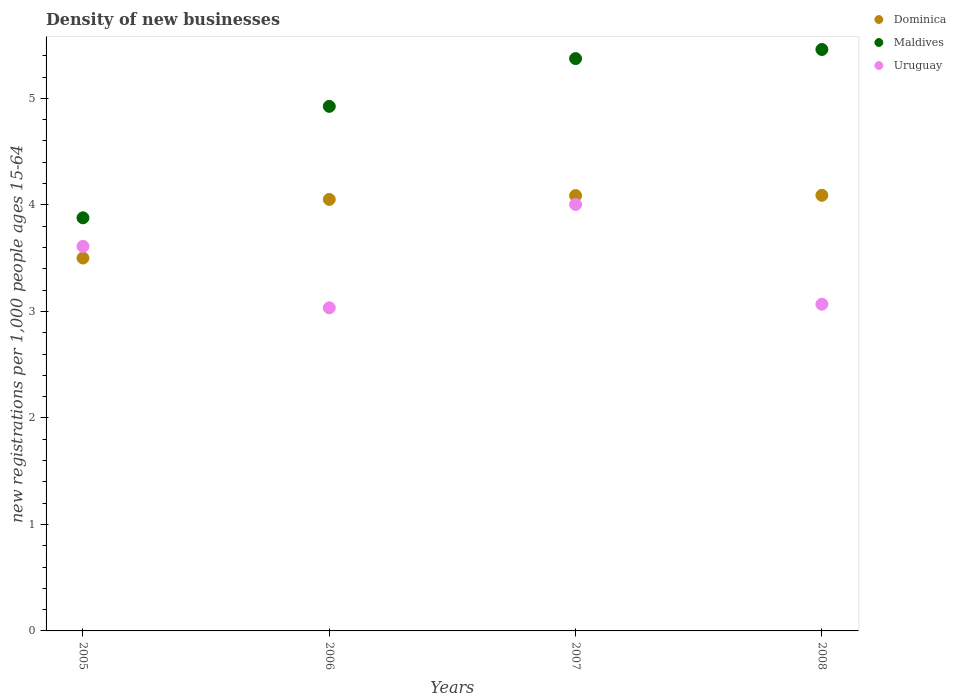How many different coloured dotlines are there?
Keep it short and to the point. 3. Is the number of dotlines equal to the number of legend labels?
Ensure brevity in your answer.  Yes. What is the number of new registrations in Maldives in 2008?
Your answer should be very brief. 5.46. Across all years, what is the maximum number of new registrations in Uruguay?
Your answer should be very brief. 4. Across all years, what is the minimum number of new registrations in Dominica?
Keep it short and to the point. 3.5. What is the total number of new registrations in Uruguay in the graph?
Provide a short and direct response. 13.72. What is the difference between the number of new registrations in Uruguay in 2007 and that in 2008?
Offer a very short reply. 0.94. What is the difference between the number of new registrations in Maldives in 2006 and the number of new registrations in Uruguay in 2008?
Ensure brevity in your answer.  1.86. What is the average number of new registrations in Uruguay per year?
Offer a very short reply. 3.43. In the year 2005, what is the difference between the number of new registrations in Maldives and number of new registrations in Dominica?
Provide a short and direct response. 0.38. What is the ratio of the number of new registrations in Uruguay in 2005 to that in 2006?
Make the answer very short. 1.19. Is the difference between the number of new registrations in Maldives in 2006 and 2007 greater than the difference between the number of new registrations in Dominica in 2006 and 2007?
Provide a succinct answer. No. What is the difference between the highest and the second highest number of new registrations in Dominica?
Offer a very short reply. 0. What is the difference between the highest and the lowest number of new registrations in Uruguay?
Keep it short and to the point. 0.97. In how many years, is the number of new registrations in Maldives greater than the average number of new registrations in Maldives taken over all years?
Provide a succinct answer. 3. Is it the case that in every year, the sum of the number of new registrations in Dominica and number of new registrations in Uruguay  is greater than the number of new registrations in Maldives?
Provide a succinct answer. Yes. Does the number of new registrations in Dominica monotonically increase over the years?
Give a very brief answer. Yes. Is the number of new registrations in Uruguay strictly greater than the number of new registrations in Maldives over the years?
Give a very brief answer. No. Is the number of new registrations in Maldives strictly less than the number of new registrations in Dominica over the years?
Your response must be concise. No. Are the values on the major ticks of Y-axis written in scientific E-notation?
Offer a terse response. No. Where does the legend appear in the graph?
Offer a very short reply. Top right. How are the legend labels stacked?
Provide a succinct answer. Vertical. What is the title of the graph?
Your response must be concise. Density of new businesses. Does "Sweden" appear as one of the legend labels in the graph?
Make the answer very short. No. What is the label or title of the X-axis?
Provide a succinct answer. Years. What is the label or title of the Y-axis?
Your response must be concise. New registrations per 1,0 people ages 15-64. What is the new registrations per 1,000 people ages 15-64 in Dominica in 2005?
Your answer should be very brief. 3.5. What is the new registrations per 1,000 people ages 15-64 of Maldives in 2005?
Give a very brief answer. 3.88. What is the new registrations per 1,000 people ages 15-64 in Uruguay in 2005?
Provide a short and direct response. 3.61. What is the new registrations per 1,000 people ages 15-64 in Dominica in 2006?
Your answer should be very brief. 4.05. What is the new registrations per 1,000 people ages 15-64 in Maldives in 2006?
Your response must be concise. 4.93. What is the new registrations per 1,000 people ages 15-64 in Uruguay in 2006?
Your response must be concise. 3.03. What is the new registrations per 1,000 people ages 15-64 of Dominica in 2007?
Offer a very short reply. 4.09. What is the new registrations per 1,000 people ages 15-64 of Maldives in 2007?
Give a very brief answer. 5.37. What is the new registrations per 1,000 people ages 15-64 of Uruguay in 2007?
Provide a succinct answer. 4. What is the new registrations per 1,000 people ages 15-64 in Dominica in 2008?
Provide a short and direct response. 4.09. What is the new registrations per 1,000 people ages 15-64 in Maldives in 2008?
Make the answer very short. 5.46. What is the new registrations per 1,000 people ages 15-64 of Uruguay in 2008?
Your response must be concise. 3.07. Across all years, what is the maximum new registrations per 1,000 people ages 15-64 of Dominica?
Provide a succinct answer. 4.09. Across all years, what is the maximum new registrations per 1,000 people ages 15-64 of Maldives?
Ensure brevity in your answer.  5.46. Across all years, what is the maximum new registrations per 1,000 people ages 15-64 of Uruguay?
Give a very brief answer. 4. Across all years, what is the minimum new registrations per 1,000 people ages 15-64 in Dominica?
Ensure brevity in your answer.  3.5. Across all years, what is the minimum new registrations per 1,000 people ages 15-64 of Maldives?
Keep it short and to the point. 3.88. Across all years, what is the minimum new registrations per 1,000 people ages 15-64 in Uruguay?
Your response must be concise. 3.03. What is the total new registrations per 1,000 people ages 15-64 in Dominica in the graph?
Your response must be concise. 15.73. What is the total new registrations per 1,000 people ages 15-64 of Maldives in the graph?
Offer a very short reply. 19.64. What is the total new registrations per 1,000 people ages 15-64 in Uruguay in the graph?
Provide a short and direct response. 13.72. What is the difference between the new registrations per 1,000 people ages 15-64 of Dominica in 2005 and that in 2006?
Your answer should be very brief. -0.55. What is the difference between the new registrations per 1,000 people ages 15-64 of Maldives in 2005 and that in 2006?
Offer a very short reply. -1.05. What is the difference between the new registrations per 1,000 people ages 15-64 of Uruguay in 2005 and that in 2006?
Your answer should be very brief. 0.58. What is the difference between the new registrations per 1,000 people ages 15-64 in Dominica in 2005 and that in 2007?
Your answer should be very brief. -0.59. What is the difference between the new registrations per 1,000 people ages 15-64 in Maldives in 2005 and that in 2007?
Give a very brief answer. -1.5. What is the difference between the new registrations per 1,000 people ages 15-64 of Uruguay in 2005 and that in 2007?
Offer a very short reply. -0.39. What is the difference between the new registrations per 1,000 people ages 15-64 in Dominica in 2005 and that in 2008?
Your answer should be compact. -0.59. What is the difference between the new registrations per 1,000 people ages 15-64 of Maldives in 2005 and that in 2008?
Provide a succinct answer. -1.58. What is the difference between the new registrations per 1,000 people ages 15-64 in Uruguay in 2005 and that in 2008?
Give a very brief answer. 0.54. What is the difference between the new registrations per 1,000 people ages 15-64 in Dominica in 2006 and that in 2007?
Offer a very short reply. -0.04. What is the difference between the new registrations per 1,000 people ages 15-64 of Maldives in 2006 and that in 2007?
Ensure brevity in your answer.  -0.45. What is the difference between the new registrations per 1,000 people ages 15-64 in Uruguay in 2006 and that in 2007?
Offer a very short reply. -0.97. What is the difference between the new registrations per 1,000 people ages 15-64 of Dominica in 2006 and that in 2008?
Offer a very short reply. -0.04. What is the difference between the new registrations per 1,000 people ages 15-64 in Maldives in 2006 and that in 2008?
Offer a terse response. -0.53. What is the difference between the new registrations per 1,000 people ages 15-64 of Uruguay in 2006 and that in 2008?
Ensure brevity in your answer.  -0.03. What is the difference between the new registrations per 1,000 people ages 15-64 in Dominica in 2007 and that in 2008?
Give a very brief answer. -0. What is the difference between the new registrations per 1,000 people ages 15-64 of Maldives in 2007 and that in 2008?
Provide a short and direct response. -0.09. What is the difference between the new registrations per 1,000 people ages 15-64 of Uruguay in 2007 and that in 2008?
Your response must be concise. 0.94. What is the difference between the new registrations per 1,000 people ages 15-64 in Dominica in 2005 and the new registrations per 1,000 people ages 15-64 in Maldives in 2006?
Your answer should be very brief. -1.42. What is the difference between the new registrations per 1,000 people ages 15-64 in Dominica in 2005 and the new registrations per 1,000 people ages 15-64 in Uruguay in 2006?
Your answer should be very brief. 0.47. What is the difference between the new registrations per 1,000 people ages 15-64 of Maldives in 2005 and the new registrations per 1,000 people ages 15-64 of Uruguay in 2006?
Provide a short and direct response. 0.84. What is the difference between the new registrations per 1,000 people ages 15-64 in Dominica in 2005 and the new registrations per 1,000 people ages 15-64 in Maldives in 2007?
Keep it short and to the point. -1.87. What is the difference between the new registrations per 1,000 people ages 15-64 of Dominica in 2005 and the new registrations per 1,000 people ages 15-64 of Uruguay in 2007?
Your answer should be very brief. -0.5. What is the difference between the new registrations per 1,000 people ages 15-64 in Maldives in 2005 and the new registrations per 1,000 people ages 15-64 in Uruguay in 2007?
Ensure brevity in your answer.  -0.13. What is the difference between the new registrations per 1,000 people ages 15-64 of Dominica in 2005 and the new registrations per 1,000 people ages 15-64 of Maldives in 2008?
Your answer should be compact. -1.96. What is the difference between the new registrations per 1,000 people ages 15-64 in Dominica in 2005 and the new registrations per 1,000 people ages 15-64 in Uruguay in 2008?
Keep it short and to the point. 0.43. What is the difference between the new registrations per 1,000 people ages 15-64 in Maldives in 2005 and the new registrations per 1,000 people ages 15-64 in Uruguay in 2008?
Your response must be concise. 0.81. What is the difference between the new registrations per 1,000 people ages 15-64 of Dominica in 2006 and the new registrations per 1,000 people ages 15-64 of Maldives in 2007?
Give a very brief answer. -1.32. What is the difference between the new registrations per 1,000 people ages 15-64 in Dominica in 2006 and the new registrations per 1,000 people ages 15-64 in Uruguay in 2007?
Ensure brevity in your answer.  0.05. What is the difference between the new registrations per 1,000 people ages 15-64 of Maldives in 2006 and the new registrations per 1,000 people ages 15-64 of Uruguay in 2007?
Give a very brief answer. 0.92. What is the difference between the new registrations per 1,000 people ages 15-64 in Dominica in 2006 and the new registrations per 1,000 people ages 15-64 in Maldives in 2008?
Offer a very short reply. -1.41. What is the difference between the new registrations per 1,000 people ages 15-64 in Dominica in 2006 and the new registrations per 1,000 people ages 15-64 in Uruguay in 2008?
Your response must be concise. 0.98. What is the difference between the new registrations per 1,000 people ages 15-64 in Maldives in 2006 and the new registrations per 1,000 people ages 15-64 in Uruguay in 2008?
Provide a short and direct response. 1.86. What is the difference between the new registrations per 1,000 people ages 15-64 of Dominica in 2007 and the new registrations per 1,000 people ages 15-64 of Maldives in 2008?
Give a very brief answer. -1.37. What is the difference between the new registrations per 1,000 people ages 15-64 of Dominica in 2007 and the new registrations per 1,000 people ages 15-64 of Uruguay in 2008?
Ensure brevity in your answer.  1.02. What is the difference between the new registrations per 1,000 people ages 15-64 of Maldives in 2007 and the new registrations per 1,000 people ages 15-64 of Uruguay in 2008?
Offer a terse response. 2.31. What is the average new registrations per 1,000 people ages 15-64 of Dominica per year?
Keep it short and to the point. 3.93. What is the average new registrations per 1,000 people ages 15-64 in Maldives per year?
Your response must be concise. 4.91. What is the average new registrations per 1,000 people ages 15-64 of Uruguay per year?
Offer a terse response. 3.43. In the year 2005, what is the difference between the new registrations per 1,000 people ages 15-64 in Dominica and new registrations per 1,000 people ages 15-64 in Maldives?
Offer a terse response. -0.38. In the year 2005, what is the difference between the new registrations per 1,000 people ages 15-64 in Dominica and new registrations per 1,000 people ages 15-64 in Uruguay?
Your response must be concise. -0.11. In the year 2005, what is the difference between the new registrations per 1,000 people ages 15-64 in Maldives and new registrations per 1,000 people ages 15-64 in Uruguay?
Ensure brevity in your answer.  0.27. In the year 2006, what is the difference between the new registrations per 1,000 people ages 15-64 in Dominica and new registrations per 1,000 people ages 15-64 in Maldives?
Offer a very short reply. -0.87. In the year 2006, what is the difference between the new registrations per 1,000 people ages 15-64 of Dominica and new registrations per 1,000 people ages 15-64 of Uruguay?
Provide a short and direct response. 1.02. In the year 2006, what is the difference between the new registrations per 1,000 people ages 15-64 in Maldives and new registrations per 1,000 people ages 15-64 in Uruguay?
Ensure brevity in your answer.  1.89. In the year 2007, what is the difference between the new registrations per 1,000 people ages 15-64 of Dominica and new registrations per 1,000 people ages 15-64 of Maldives?
Your response must be concise. -1.29. In the year 2007, what is the difference between the new registrations per 1,000 people ages 15-64 in Dominica and new registrations per 1,000 people ages 15-64 in Uruguay?
Keep it short and to the point. 0.08. In the year 2007, what is the difference between the new registrations per 1,000 people ages 15-64 in Maldives and new registrations per 1,000 people ages 15-64 in Uruguay?
Your response must be concise. 1.37. In the year 2008, what is the difference between the new registrations per 1,000 people ages 15-64 in Dominica and new registrations per 1,000 people ages 15-64 in Maldives?
Offer a terse response. -1.37. In the year 2008, what is the difference between the new registrations per 1,000 people ages 15-64 in Dominica and new registrations per 1,000 people ages 15-64 in Uruguay?
Keep it short and to the point. 1.02. In the year 2008, what is the difference between the new registrations per 1,000 people ages 15-64 in Maldives and new registrations per 1,000 people ages 15-64 in Uruguay?
Ensure brevity in your answer.  2.39. What is the ratio of the new registrations per 1,000 people ages 15-64 in Dominica in 2005 to that in 2006?
Offer a very short reply. 0.86. What is the ratio of the new registrations per 1,000 people ages 15-64 in Maldives in 2005 to that in 2006?
Offer a terse response. 0.79. What is the ratio of the new registrations per 1,000 people ages 15-64 in Uruguay in 2005 to that in 2006?
Give a very brief answer. 1.19. What is the ratio of the new registrations per 1,000 people ages 15-64 of Dominica in 2005 to that in 2007?
Your response must be concise. 0.86. What is the ratio of the new registrations per 1,000 people ages 15-64 in Maldives in 2005 to that in 2007?
Make the answer very short. 0.72. What is the ratio of the new registrations per 1,000 people ages 15-64 in Uruguay in 2005 to that in 2007?
Your response must be concise. 0.9. What is the ratio of the new registrations per 1,000 people ages 15-64 of Dominica in 2005 to that in 2008?
Give a very brief answer. 0.86. What is the ratio of the new registrations per 1,000 people ages 15-64 of Maldives in 2005 to that in 2008?
Offer a very short reply. 0.71. What is the ratio of the new registrations per 1,000 people ages 15-64 in Uruguay in 2005 to that in 2008?
Provide a succinct answer. 1.18. What is the ratio of the new registrations per 1,000 people ages 15-64 of Dominica in 2006 to that in 2007?
Make the answer very short. 0.99. What is the ratio of the new registrations per 1,000 people ages 15-64 of Maldives in 2006 to that in 2007?
Give a very brief answer. 0.92. What is the ratio of the new registrations per 1,000 people ages 15-64 of Uruguay in 2006 to that in 2007?
Your answer should be very brief. 0.76. What is the ratio of the new registrations per 1,000 people ages 15-64 of Dominica in 2006 to that in 2008?
Ensure brevity in your answer.  0.99. What is the ratio of the new registrations per 1,000 people ages 15-64 in Maldives in 2006 to that in 2008?
Offer a very short reply. 0.9. What is the ratio of the new registrations per 1,000 people ages 15-64 of Uruguay in 2006 to that in 2008?
Provide a succinct answer. 0.99. What is the ratio of the new registrations per 1,000 people ages 15-64 of Dominica in 2007 to that in 2008?
Your answer should be very brief. 1. What is the ratio of the new registrations per 1,000 people ages 15-64 in Maldives in 2007 to that in 2008?
Offer a very short reply. 0.98. What is the ratio of the new registrations per 1,000 people ages 15-64 in Uruguay in 2007 to that in 2008?
Your answer should be compact. 1.31. What is the difference between the highest and the second highest new registrations per 1,000 people ages 15-64 of Dominica?
Your response must be concise. 0. What is the difference between the highest and the second highest new registrations per 1,000 people ages 15-64 of Maldives?
Keep it short and to the point. 0.09. What is the difference between the highest and the second highest new registrations per 1,000 people ages 15-64 in Uruguay?
Make the answer very short. 0.39. What is the difference between the highest and the lowest new registrations per 1,000 people ages 15-64 in Dominica?
Ensure brevity in your answer.  0.59. What is the difference between the highest and the lowest new registrations per 1,000 people ages 15-64 of Maldives?
Provide a short and direct response. 1.58. What is the difference between the highest and the lowest new registrations per 1,000 people ages 15-64 in Uruguay?
Your answer should be compact. 0.97. 